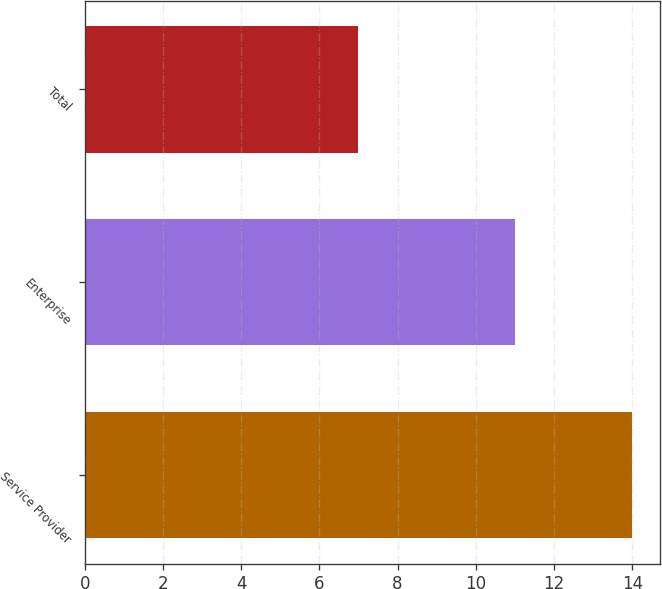Convert chart. <chart><loc_0><loc_0><loc_500><loc_500><bar_chart><fcel>Service Provider<fcel>Enterprise<fcel>Total<nl><fcel>14<fcel>11<fcel>7<nl></chart> 